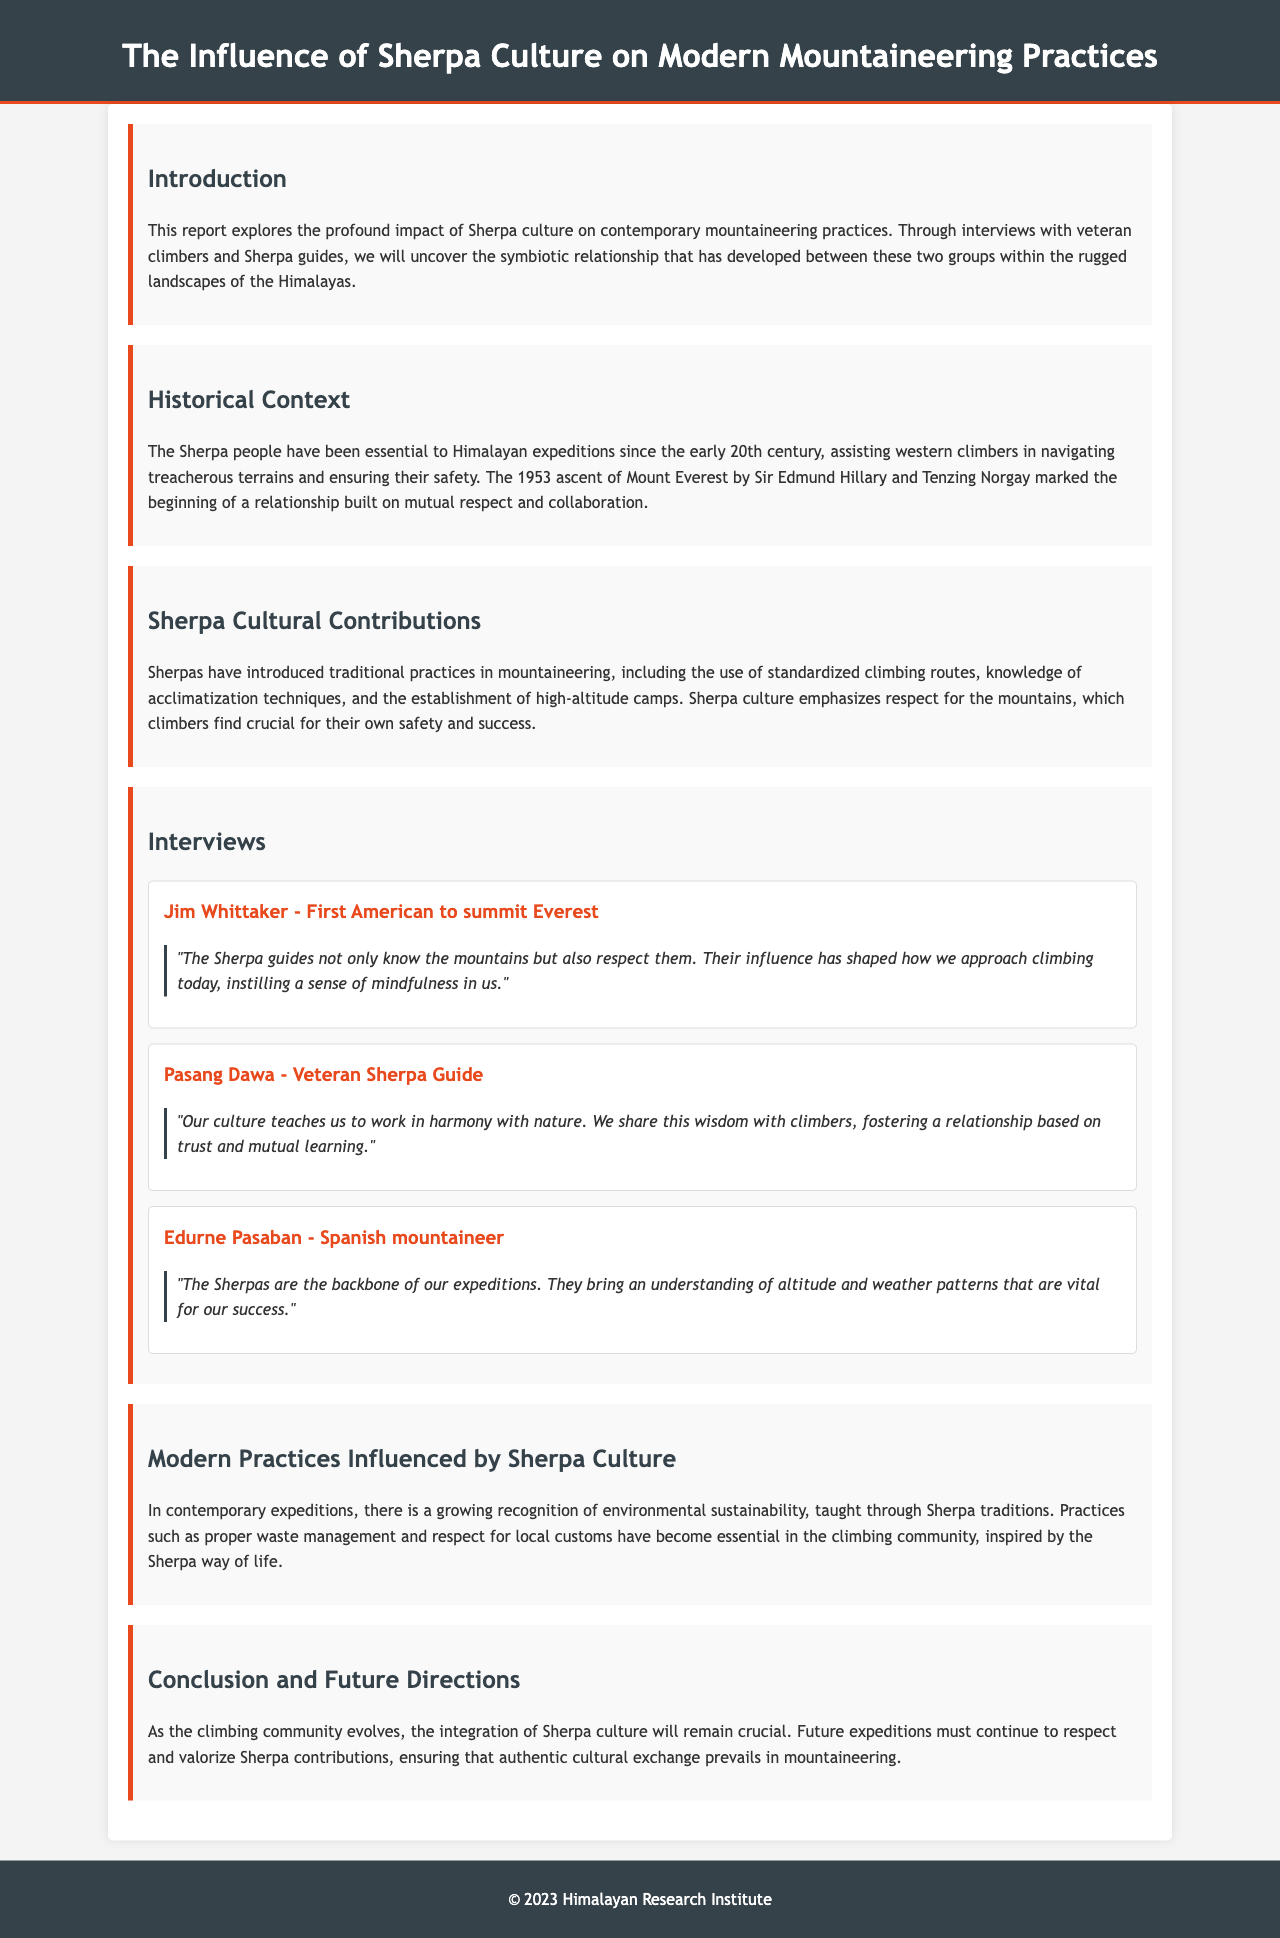what is the title of the report? The title is prominently displayed at the top of the document.
Answer: The Influence of Sherpa Culture on Modern Mountaineering Practices who was the first American to summit Everest? This information is found in the interviews section of the report.
Answer: Jim Whittaker what year did Sir Edmund Hillary and Tenzing Norgay ascend Mount Everest? This date is mentioned in the historical context section of the document.
Answer: 1953 what is emphasized by Sherpa culture during expeditions? This concept is discussed in the cultural contributions section.
Answer: Respect for the mountains who is a veteran Sherpa guide interviewed in the report? This can be found in the interviews section where guides are named.
Answer: Pasang Dawa what modern practice is influenced by Sherpa culture? The document discusses various practices in the modern practices section.
Answer: Environmental sustainability what does Edurne Pasaban say about Sherpas? This information is taken from her quote in the interviews section.
Answer: Backbone of our expeditions what is the primary focus of the report? The introduction outlines the overall purpose of the document.
Answer: The impact of Sherpa culture on mountaineering practices 